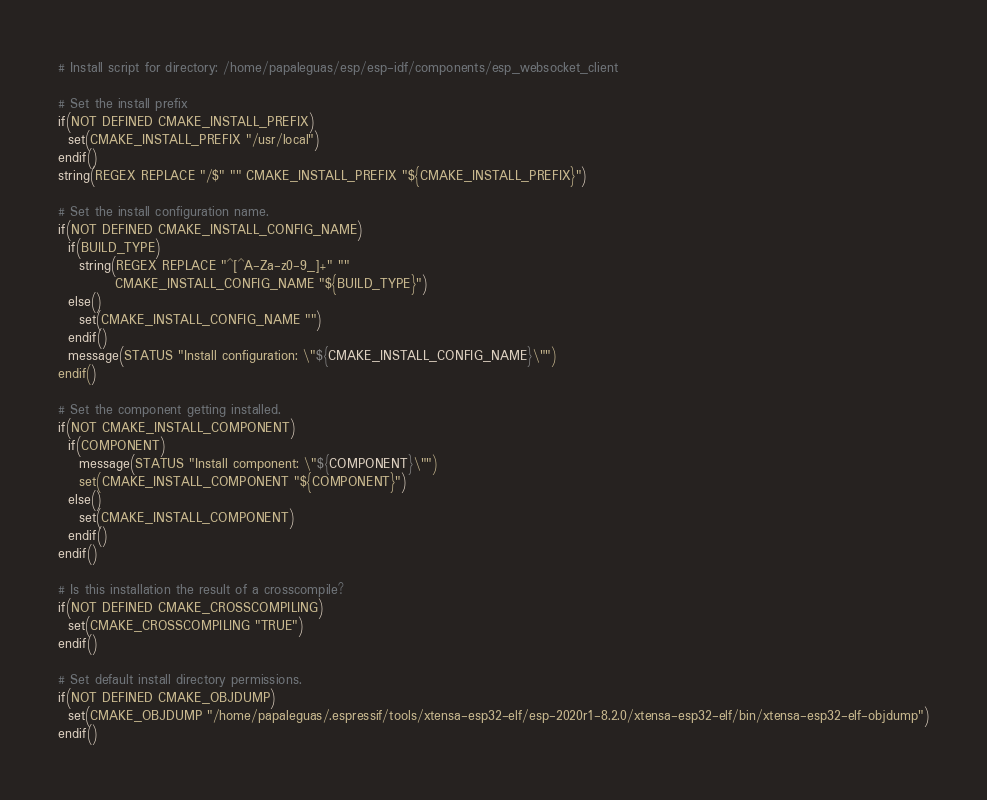Convert code to text. <code><loc_0><loc_0><loc_500><loc_500><_CMake_># Install script for directory: /home/papaleguas/esp/esp-idf/components/esp_websocket_client

# Set the install prefix
if(NOT DEFINED CMAKE_INSTALL_PREFIX)
  set(CMAKE_INSTALL_PREFIX "/usr/local")
endif()
string(REGEX REPLACE "/$" "" CMAKE_INSTALL_PREFIX "${CMAKE_INSTALL_PREFIX}")

# Set the install configuration name.
if(NOT DEFINED CMAKE_INSTALL_CONFIG_NAME)
  if(BUILD_TYPE)
    string(REGEX REPLACE "^[^A-Za-z0-9_]+" ""
           CMAKE_INSTALL_CONFIG_NAME "${BUILD_TYPE}")
  else()
    set(CMAKE_INSTALL_CONFIG_NAME "")
  endif()
  message(STATUS "Install configuration: \"${CMAKE_INSTALL_CONFIG_NAME}\"")
endif()

# Set the component getting installed.
if(NOT CMAKE_INSTALL_COMPONENT)
  if(COMPONENT)
    message(STATUS "Install component: \"${COMPONENT}\"")
    set(CMAKE_INSTALL_COMPONENT "${COMPONENT}")
  else()
    set(CMAKE_INSTALL_COMPONENT)
  endif()
endif()

# Is this installation the result of a crosscompile?
if(NOT DEFINED CMAKE_CROSSCOMPILING)
  set(CMAKE_CROSSCOMPILING "TRUE")
endif()

# Set default install directory permissions.
if(NOT DEFINED CMAKE_OBJDUMP)
  set(CMAKE_OBJDUMP "/home/papaleguas/.espressif/tools/xtensa-esp32-elf/esp-2020r1-8.2.0/xtensa-esp32-elf/bin/xtensa-esp32-elf-objdump")
endif()

</code> 